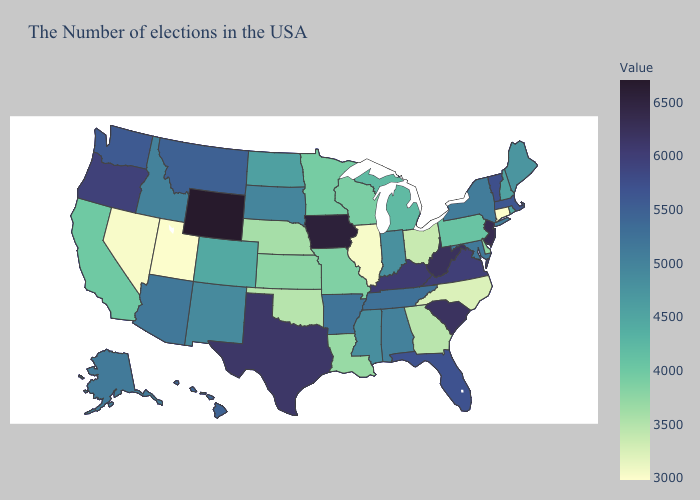Does Rhode Island have the highest value in the USA?
Give a very brief answer. No. Does Wyoming have the highest value in the USA?
Answer briefly. Yes. Does Mississippi have the highest value in the USA?
Concise answer only. No. Which states have the lowest value in the West?
Write a very short answer. Utah. Does Iowa have the highest value in the USA?
Keep it brief. No. Which states hav the highest value in the South?
Keep it brief. West Virginia. Does Connecticut have the lowest value in the Northeast?
Concise answer only. Yes. 